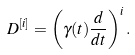Convert formula to latex. <formula><loc_0><loc_0><loc_500><loc_500>D ^ { [ i ] } = \left ( \gamma ( t ) \frac { d } { d t } \right ) ^ { i } .</formula> 